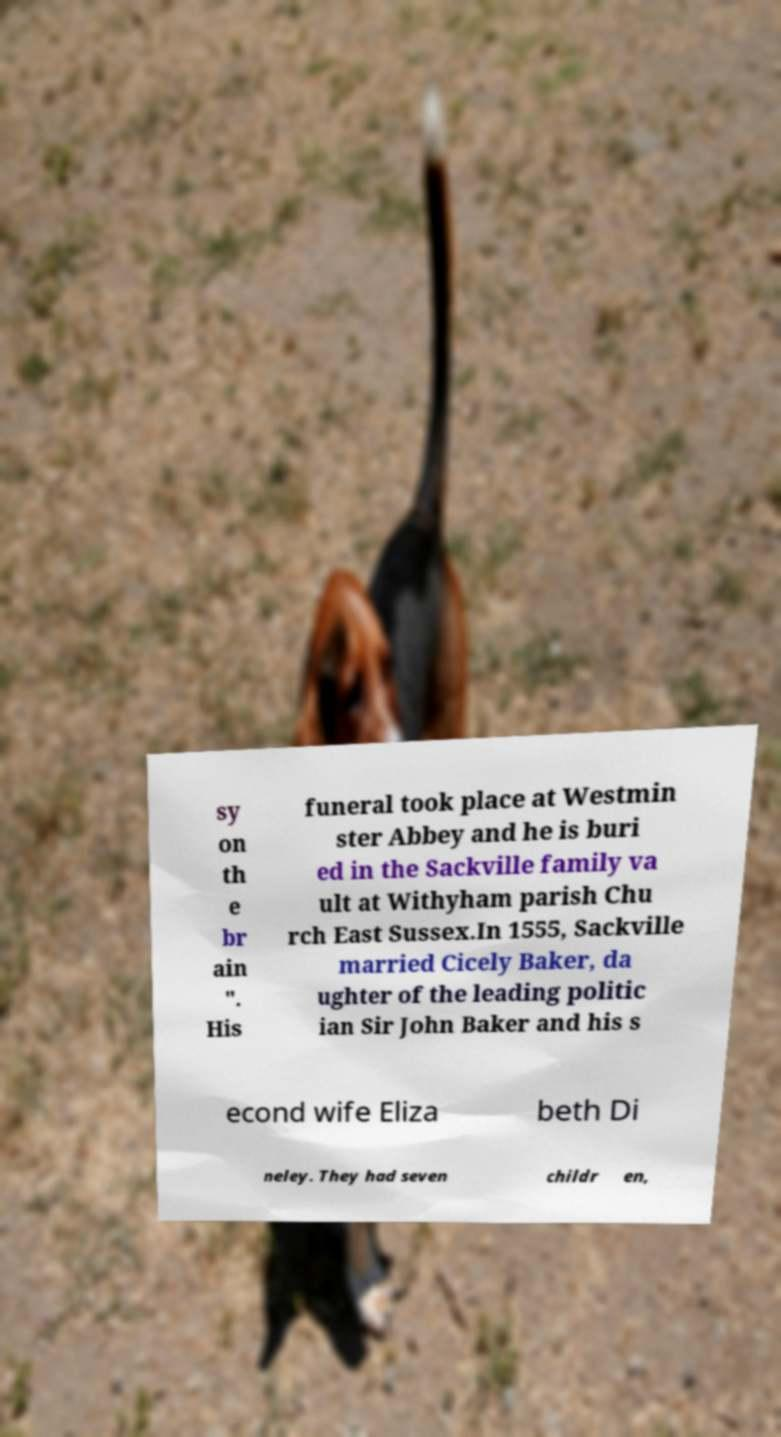Please identify and transcribe the text found in this image. sy on th e br ain ". His funeral took place at Westmin ster Abbey and he is buri ed in the Sackville family va ult at Withyham parish Chu rch East Sussex.In 1555, Sackville married Cicely Baker, da ughter of the leading politic ian Sir John Baker and his s econd wife Eliza beth Di neley. They had seven childr en, 